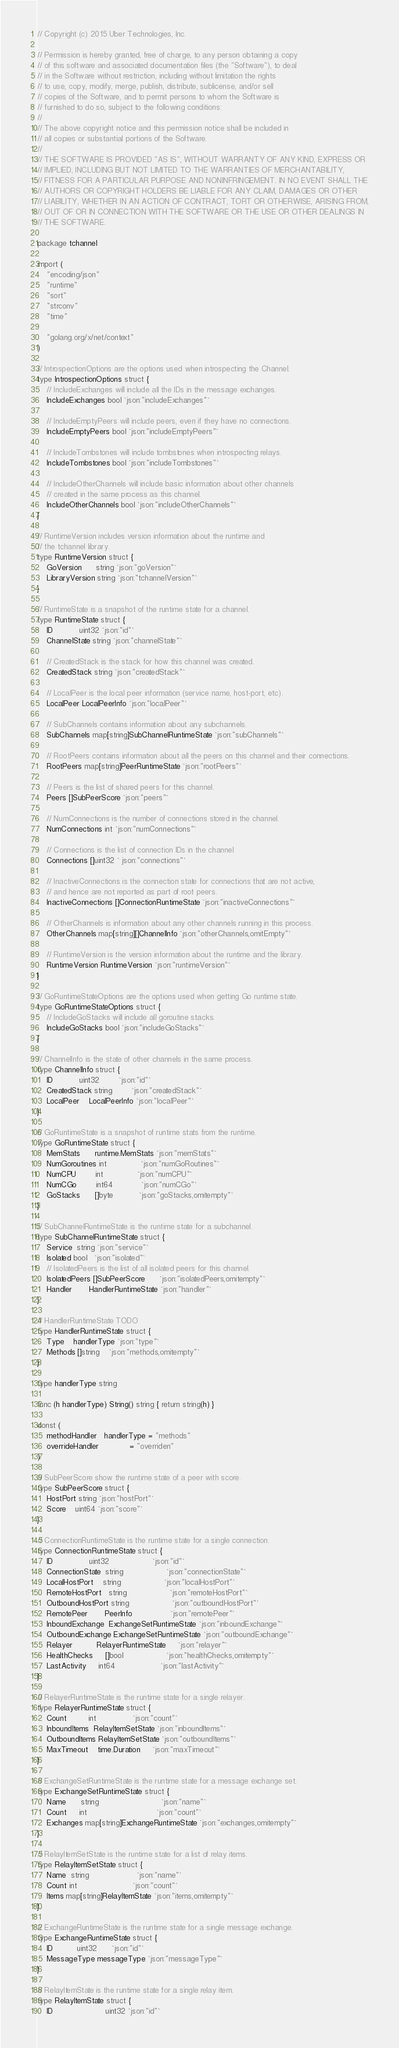Convert code to text. <code><loc_0><loc_0><loc_500><loc_500><_Go_>// Copyright (c) 2015 Uber Technologies, Inc.

// Permission is hereby granted, free of charge, to any person obtaining a copy
// of this software and associated documentation files (the "Software"), to deal
// in the Software without restriction, including without limitation the rights
// to use, copy, modify, merge, publish, distribute, sublicense, and/or sell
// copies of the Software, and to permit persons to whom the Software is
// furnished to do so, subject to the following conditions:
//
// The above copyright notice and this permission notice shall be included in
// all copies or substantial portions of the Software.
//
// THE SOFTWARE IS PROVIDED "AS IS", WITHOUT WARRANTY OF ANY KIND, EXPRESS OR
// IMPLIED, INCLUDING BUT NOT LIMITED TO THE WARRANTIES OF MERCHANTABILITY,
// FITNESS FOR A PARTICULAR PURPOSE AND NONINFRINGEMENT. IN NO EVENT SHALL THE
// AUTHORS OR COPYRIGHT HOLDERS BE LIABLE FOR ANY CLAIM, DAMAGES OR OTHER
// LIABILITY, WHETHER IN AN ACTION OF CONTRACT, TORT OR OTHERWISE, ARISING FROM,
// OUT OF OR IN CONNECTION WITH THE SOFTWARE OR THE USE OR OTHER DEALINGS IN
// THE SOFTWARE.

package tchannel

import (
	"encoding/json"
	"runtime"
	"sort"
	"strconv"
	"time"

	"golang.org/x/net/context"
)

// IntrospectionOptions are the options used when introspecting the Channel.
type IntrospectionOptions struct {
	// IncludeExchanges will include all the IDs in the message exchanges.
	IncludeExchanges bool `json:"includeExchanges"`

	// IncludeEmptyPeers will include peers, even if they have no connections.
	IncludeEmptyPeers bool `json:"includeEmptyPeers"`

	// IncludeTombstones will include tombstones when introspecting relays.
	IncludeTombstones bool `json:"includeTombstones"`

	// IncludeOtherChannels will include basic information about other channels
	// created in the same process as this channel.
	IncludeOtherChannels bool `json:"includeOtherChannels"`
}

// RuntimeVersion includes version information about the runtime and
// the tchannel library.
type RuntimeVersion struct {
	GoVersion      string `json:"goVersion"`
	LibraryVersion string `json:"tchannelVersion"`
}

// RuntimeState is a snapshot of the runtime state for a channel.
type RuntimeState struct {
	ID           uint32 `json:"id"`
	ChannelState string `json:"channelState"`

	// CreatedStack is the stack for how this channel was created.
	CreatedStack string `json:"createdStack"`

	// LocalPeer is the local peer information (service name, host-port, etc).
	LocalPeer LocalPeerInfo `json:"localPeer"`

	// SubChannels contains information about any subchannels.
	SubChannels map[string]SubChannelRuntimeState `json:"subChannels"`

	// RootPeers contains information about all the peers on this channel and their connections.
	RootPeers map[string]PeerRuntimeState `json:"rootPeers"`

	// Peers is the list of shared peers for this channel.
	Peers []SubPeerScore `json:"peers"`

	// NumConnections is the number of connections stored in the channel.
	NumConnections int `json:"numConnections"`

	// Connections is the list of connection IDs in the channel
	Connections []uint32 ` json:"connections"`

	// InactiveConnections is the connection state for connections that are not active,
	// and hence are not reported as part of root peers.
	InactiveConnections []ConnectionRuntimeState `json:"inactiveConnections"`

	// OtherChannels is information about any other channels running in this process.
	OtherChannels map[string][]ChannelInfo `json:"otherChannels,omitEmpty"`

	// RuntimeVersion is the version information about the runtime and the library.
	RuntimeVersion RuntimeVersion `json:"runtimeVersion"`
}

// GoRuntimeStateOptions are the options used when getting Go runtime state.
type GoRuntimeStateOptions struct {
	// IncludeGoStacks will include all goroutine stacks.
	IncludeGoStacks bool `json:"includeGoStacks"`
}

// ChannelInfo is the state of other channels in the same process.
type ChannelInfo struct {
	ID           uint32        `json:"id"`
	CreatedStack string        `json:"createdStack"`
	LocalPeer    LocalPeerInfo `json:"localPeer"`
}

// GoRuntimeState is a snapshot of runtime stats from the runtime.
type GoRuntimeState struct {
	MemStats      runtime.MemStats `json:"memStats"`
	NumGoroutines int              `json:"numGoRoutines"`
	NumCPU        int              `json:"numCPU"`
	NumCGo        int64            `json:"numCGo"`
	GoStacks      []byte           `json:"goStacks,omitempty"`
}

// SubChannelRuntimeState is the runtime state for a subchannel.
type SubChannelRuntimeState struct {
	Service  string `json:"service"`
	Isolated bool   `json:"isolated"`
	// IsolatedPeers is the list of all isolated peers for this channel.
	IsolatedPeers []SubPeerScore      `json:"isolatedPeers,omitempty"`
	Handler       HandlerRuntimeState `json:"handler"`
}

// HandlerRuntimeState TODO
type HandlerRuntimeState struct {
	Type    handlerType `json:"type"`
	Methods []string    `json:"methods,omitempty"`
}

type handlerType string

func (h handlerType) String() string { return string(h) }

const (
	methodHandler   handlerType = "methods"
	overrideHandler             = "overriden"
)

// SubPeerScore show the runtime state of a peer with score.
type SubPeerScore struct {
	HostPort string `json:"hostPort"`
	Score    uint64 `json:"score"`
}

// ConnectionRuntimeState is the runtime state for a single connection.
type ConnectionRuntimeState struct {
	ID               uint32                  `json:"id"`
	ConnectionState  string                  `json:"connectionState"`
	LocalHostPort    string                  `json:"localHostPort"`
	RemoteHostPort   string                  `json:"remoteHostPort"`
	OutboundHostPort string                  `json:"outboundHostPort"`
	RemotePeer       PeerInfo                `json:"remotePeer"`
	InboundExchange  ExchangeSetRuntimeState `json:"inboundExchange"`
	OutboundExchange ExchangeSetRuntimeState `json:"outboundExchange"`
	Relayer          RelayerRuntimeState     `json:"relayer"`
	HealthChecks     []bool                  `json:"healthChecks,omitempty"`
	LastActivity     int64                   `json:"lastActivity"`
}

// RelayerRuntimeState is the runtime state for a single relayer.
type RelayerRuntimeState struct {
	Count         int               `json:"count"`
	InboundItems  RelayItemSetState `json:"inboundItems"`
	OutboundItems RelayItemSetState `json:"outboundItems"`
	MaxTimeout    time.Duration     `json:"maxTimeout"`
}

// ExchangeSetRuntimeState is the runtime state for a message exchange set.
type ExchangeSetRuntimeState struct {
	Name      string                          `json:"name"`
	Count     int                             `json:"count"`
	Exchanges map[string]ExchangeRuntimeState `json:"exchanges,omitempty"`
}

// RelayItemSetState is the runtime state for a list of relay items.
type RelayItemSetState struct {
	Name  string                    `json:"name"`
	Count int                       `json:"count"`
	Items map[string]RelayItemState `json:"items,omitempty"`
}

// ExchangeRuntimeState is the runtime state for a single message exchange.
type ExchangeRuntimeState struct {
	ID          uint32      `json:"id"`
	MessageType messageType `json:"messageType"`
}

// RelayItemState is the runtime state for a single relay item.
type RelayItemState struct {
	ID                      uint32 `json:"id"`</code> 